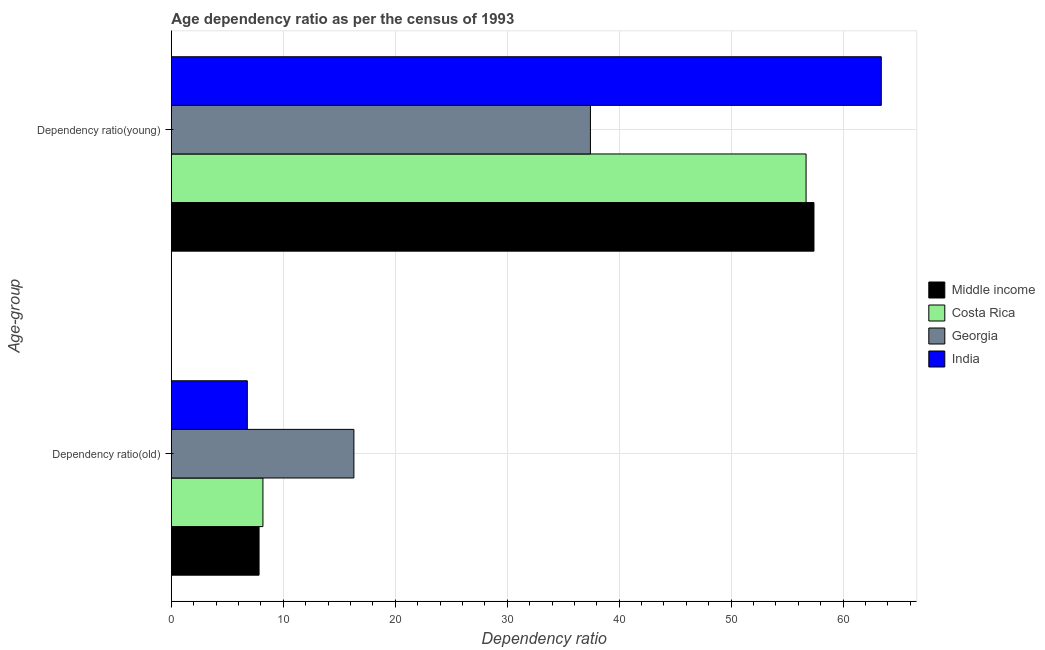How many different coloured bars are there?
Provide a short and direct response. 4. Are the number of bars per tick equal to the number of legend labels?
Keep it short and to the point. Yes. How many bars are there on the 2nd tick from the bottom?
Offer a very short reply. 4. What is the label of the 2nd group of bars from the top?
Offer a terse response. Dependency ratio(old). What is the age dependency ratio(young) in Georgia?
Give a very brief answer. 37.43. Across all countries, what is the maximum age dependency ratio(old)?
Give a very brief answer. 16.3. Across all countries, what is the minimum age dependency ratio(young)?
Give a very brief answer. 37.43. In which country was the age dependency ratio(old) maximum?
Give a very brief answer. Georgia. In which country was the age dependency ratio(young) minimum?
Give a very brief answer. Georgia. What is the total age dependency ratio(young) in the graph?
Offer a very short reply. 214.95. What is the difference between the age dependency ratio(young) in Middle income and that in Costa Rica?
Give a very brief answer. 0.7. What is the difference between the age dependency ratio(young) in Georgia and the age dependency ratio(old) in Costa Rica?
Offer a terse response. 29.26. What is the average age dependency ratio(young) per country?
Give a very brief answer. 53.74. What is the difference between the age dependency ratio(old) and age dependency ratio(young) in Middle income?
Your response must be concise. -49.57. In how many countries, is the age dependency ratio(old) greater than 6 ?
Offer a very short reply. 4. What is the ratio of the age dependency ratio(young) in Middle income to that in Georgia?
Provide a succinct answer. 1.53. Is the age dependency ratio(young) in Costa Rica less than that in India?
Provide a short and direct response. Yes. How many countries are there in the graph?
Your response must be concise. 4. What is the difference between two consecutive major ticks on the X-axis?
Your answer should be compact. 10. Where does the legend appear in the graph?
Your answer should be very brief. Center right. How many legend labels are there?
Offer a terse response. 4. How are the legend labels stacked?
Offer a very short reply. Vertical. What is the title of the graph?
Ensure brevity in your answer.  Age dependency ratio as per the census of 1993. Does "Qatar" appear as one of the legend labels in the graph?
Make the answer very short. No. What is the label or title of the X-axis?
Your answer should be compact. Dependency ratio. What is the label or title of the Y-axis?
Provide a succinct answer. Age-group. What is the Dependency ratio of Middle income in Dependency ratio(old)?
Keep it short and to the point. 7.83. What is the Dependency ratio in Costa Rica in Dependency ratio(old)?
Your answer should be very brief. 8.18. What is the Dependency ratio in Georgia in Dependency ratio(old)?
Offer a very short reply. 16.3. What is the Dependency ratio of India in Dependency ratio(old)?
Give a very brief answer. 6.78. What is the Dependency ratio of Middle income in Dependency ratio(young)?
Offer a very short reply. 57.4. What is the Dependency ratio of Costa Rica in Dependency ratio(young)?
Offer a very short reply. 56.7. What is the Dependency ratio of Georgia in Dependency ratio(young)?
Your answer should be compact. 37.43. What is the Dependency ratio of India in Dependency ratio(young)?
Your answer should be very brief. 63.42. Across all Age-group, what is the maximum Dependency ratio of Middle income?
Provide a short and direct response. 57.4. Across all Age-group, what is the maximum Dependency ratio of Costa Rica?
Your answer should be compact. 56.7. Across all Age-group, what is the maximum Dependency ratio of Georgia?
Your answer should be compact. 37.43. Across all Age-group, what is the maximum Dependency ratio of India?
Keep it short and to the point. 63.42. Across all Age-group, what is the minimum Dependency ratio of Middle income?
Ensure brevity in your answer.  7.83. Across all Age-group, what is the minimum Dependency ratio in Costa Rica?
Your response must be concise. 8.18. Across all Age-group, what is the minimum Dependency ratio in Georgia?
Offer a very short reply. 16.3. Across all Age-group, what is the minimum Dependency ratio in India?
Your response must be concise. 6.78. What is the total Dependency ratio of Middle income in the graph?
Your answer should be very brief. 65.24. What is the total Dependency ratio in Costa Rica in the graph?
Give a very brief answer. 64.88. What is the total Dependency ratio of Georgia in the graph?
Provide a succinct answer. 53.74. What is the total Dependency ratio of India in the graph?
Offer a very short reply. 70.2. What is the difference between the Dependency ratio of Middle income in Dependency ratio(old) and that in Dependency ratio(young)?
Provide a succinct answer. -49.57. What is the difference between the Dependency ratio of Costa Rica in Dependency ratio(old) and that in Dependency ratio(young)?
Your answer should be very brief. -48.52. What is the difference between the Dependency ratio of Georgia in Dependency ratio(old) and that in Dependency ratio(young)?
Give a very brief answer. -21.13. What is the difference between the Dependency ratio of India in Dependency ratio(old) and that in Dependency ratio(young)?
Make the answer very short. -56.63. What is the difference between the Dependency ratio of Middle income in Dependency ratio(old) and the Dependency ratio of Costa Rica in Dependency ratio(young)?
Provide a succinct answer. -48.87. What is the difference between the Dependency ratio in Middle income in Dependency ratio(old) and the Dependency ratio in Georgia in Dependency ratio(young)?
Offer a very short reply. -29.6. What is the difference between the Dependency ratio of Middle income in Dependency ratio(old) and the Dependency ratio of India in Dependency ratio(young)?
Your response must be concise. -55.58. What is the difference between the Dependency ratio in Costa Rica in Dependency ratio(old) and the Dependency ratio in Georgia in Dependency ratio(young)?
Your answer should be compact. -29.26. What is the difference between the Dependency ratio in Costa Rica in Dependency ratio(old) and the Dependency ratio in India in Dependency ratio(young)?
Give a very brief answer. -55.24. What is the difference between the Dependency ratio of Georgia in Dependency ratio(old) and the Dependency ratio of India in Dependency ratio(young)?
Keep it short and to the point. -47.11. What is the average Dependency ratio in Middle income per Age-group?
Give a very brief answer. 32.62. What is the average Dependency ratio in Costa Rica per Age-group?
Your answer should be compact. 32.44. What is the average Dependency ratio of Georgia per Age-group?
Give a very brief answer. 26.87. What is the average Dependency ratio of India per Age-group?
Provide a short and direct response. 35.1. What is the difference between the Dependency ratio in Middle income and Dependency ratio in Costa Rica in Dependency ratio(old)?
Offer a terse response. -0.35. What is the difference between the Dependency ratio in Middle income and Dependency ratio in Georgia in Dependency ratio(old)?
Keep it short and to the point. -8.47. What is the difference between the Dependency ratio in Middle income and Dependency ratio in India in Dependency ratio(old)?
Your response must be concise. 1.05. What is the difference between the Dependency ratio of Costa Rica and Dependency ratio of Georgia in Dependency ratio(old)?
Provide a short and direct response. -8.13. What is the difference between the Dependency ratio of Costa Rica and Dependency ratio of India in Dependency ratio(old)?
Your response must be concise. 1.39. What is the difference between the Dependency ratio of Georgia and Dependency ratio of India in Dependency ratio(old)?
Offer a very short reply. 9.52. What is the difference between the Dependency ratio in Middle income and Dependency ratio in Costa Rica in Dependency ratio(young)?
Your answer should be compact. 0.7. What is the difference between the Dependency ratio of Middle income and Dependency ratio of Georgia in Dependency ratio(young)?
Offer a very short reply. 19.97. What is the difference between the Dependency ratio of Middle income and Dependency ratio of India in Dependency ratio(young)?
Ensure brevity in your answer.  -6.01. What is the difference between the Dependency ratio in Costa Rica and Dependency ratio in Georgia in Dependency ratio(young)?
Your answer should be compact. 19.26. What is the difference between the Dependency ratio in Costa Rica and Dependency ratio in India in Dependency ratio(young)?
Ensure brevity in your answer.  -6.72. What is the difference between the Dependency ratio in Georgia and Dependency ratio in India in Dependency ratio(young)?
Provide a short and direct response. -25.98. What is the ratio of the Dependency ratio of Middle income in Dependency ratio(old) to that in Dependency ratio(young)?
Give a very brief answer. 0.14. What is the ratio of the Dependency ratio in Costa Rica in Dependency ratio(old) to that in Dependency ratio(young)?
Give a very brief answer. 0.14. What is the ratio of the Dependency ratio in Georgia in Dependency ratio(old) to that in Dependency ratio(young)?
Your response must be concise. 0.44. What is the ratio of the Dependency ratio in India in Dependency ratio(old) to that in Dependency ratio(young)?
Your answer should be very brief. 0.11. What is the difference between the highest and the second highest Dependency ratio in Middle income?
Your answer should be compact. 49.57. What is the difference between the highest and the second highest Dependency ratio of Costa Rica?
Offer a terse response. 48.52. What is the difference between the highest and the second highest Dependency ratio in Georgia?
Ensure brevity in your answer.  21.13. What is the difference between the highest and the second highest Dependency ratio in India?
Your answer should be very brief. 56.63. What is the difference between the highest and the lowest Dependency ratio of Middle income?
Provide a short and direct response. 49.57. What is the difference between the highest and the lowest Dependency ratio in Costa Rica?
Offer a very short reply. 48.52. What is the difference between the highest and the lowest Dependency ratio in Georgia?
Your answer should be very brief. 21.13. What is the difference between the highest and the lowest Dependency ratio in India?
Your response must be concise. 56.63. 